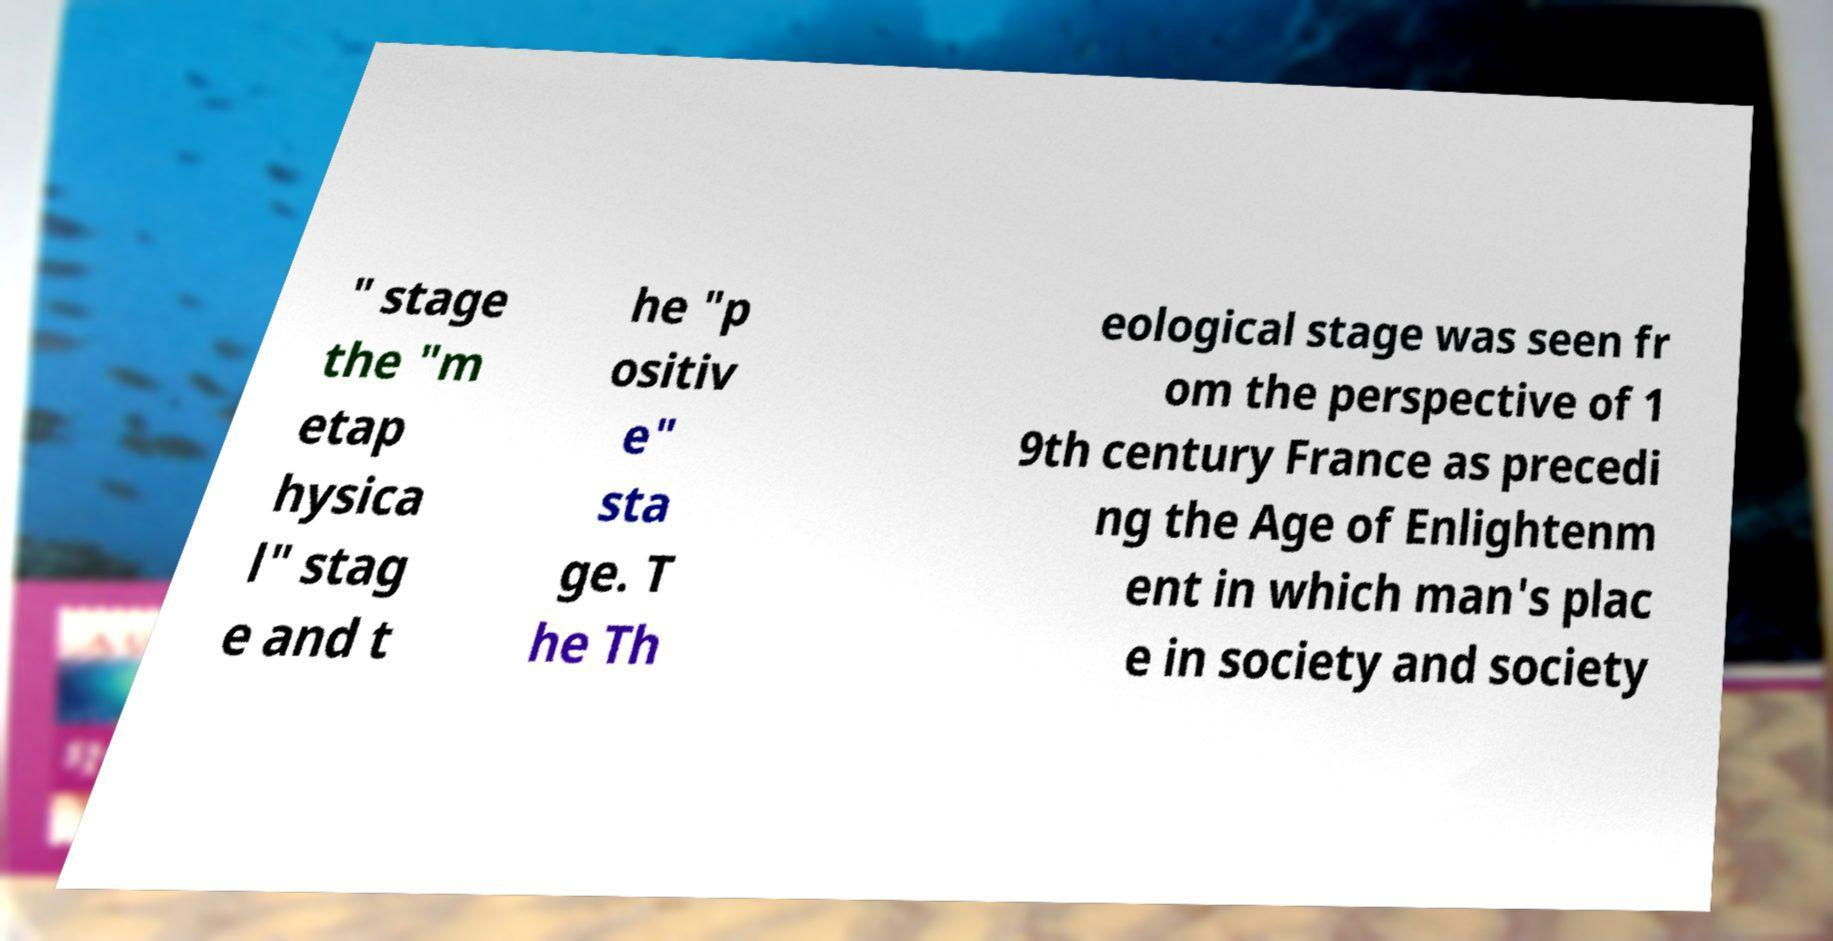Please identify and transcribe the text found in this image. " stage the "m etap hysica l" stag e and t he "p ositiv e" sta ge. T he Th eological stage was seen fr om the perspective of 1 9th century France as precedi ng the Age of Enlightenm ent in which man's plac e in society and society 